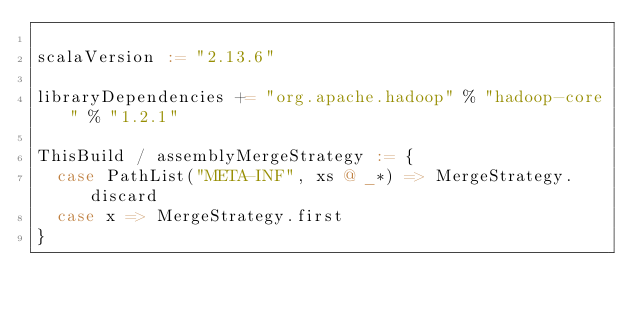<code> <loc_0><loc_0><loc_500><loc_500><_Scala_>
scalaVersion := "2.13.6"

libraryDependencies += "org.apache.hadoop" % "hadoop-core" % "1.2.1"

ThisBuild / assemblyMergeStrategy := {
  case PathList("META-INF", xs @ _*) => MergeStrategy.discard
  case x => MergeStrategy.first
}</code> 